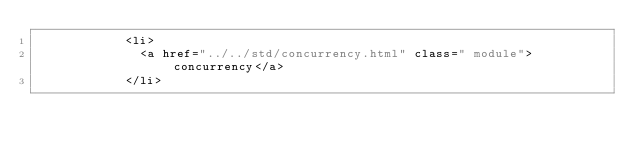<code> <loc_0><loc_0><loc_500><loc_500><_HTML_>						<li>
							<a href="../../std/concurrency.html" class=" module">concurrency</a>
						</li></code> 